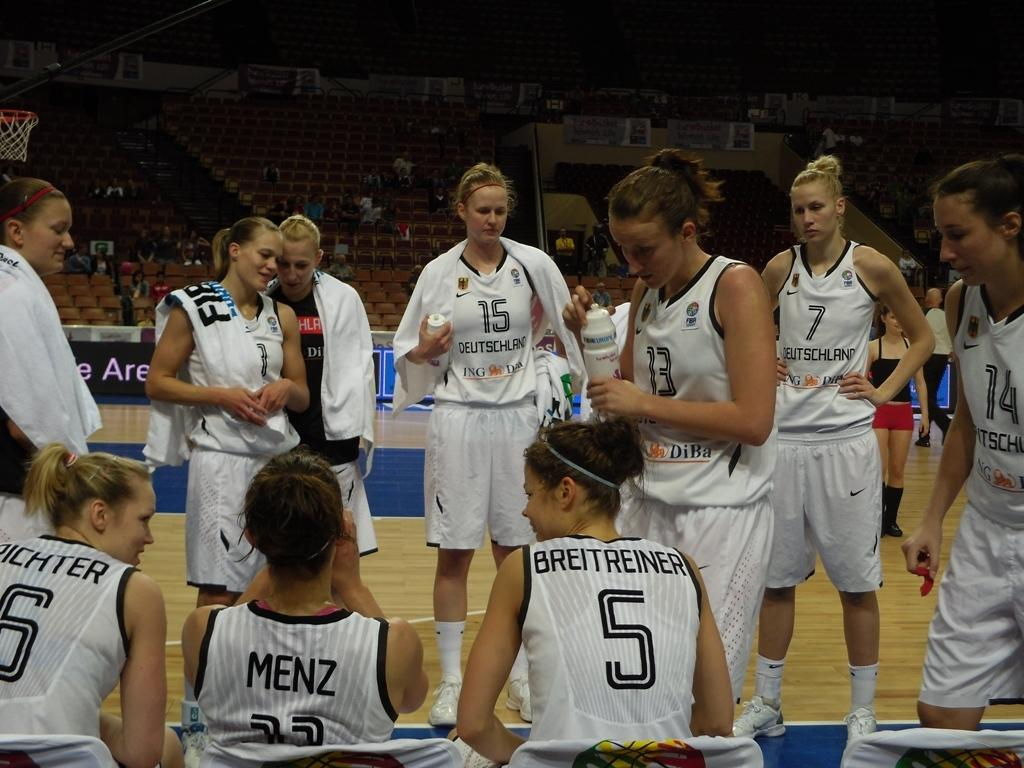<image>
Share a concise interpretation of the image provided. Basketball player wearing number 5 sitting on the bench talking to her teammates. 